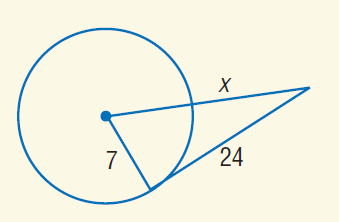Question: Find x. Assume that segments that appear to be tangent are tangent.
Choices:
A. 3
B. 7
C. 18
D. 24
Answer with the letter. Answer: C 